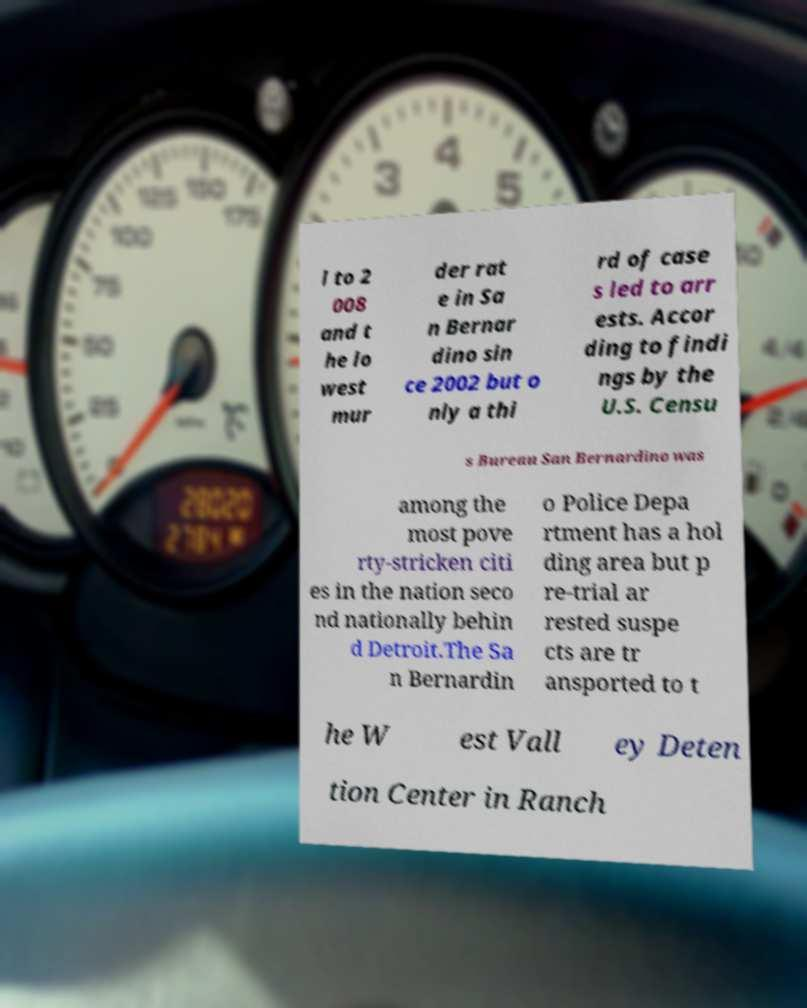For documentation purposes, I need the text within this image transcribed. Could you provide that? l to 2 008 and t he lo west mur der rat e in Sa n Bernar dino sin ce 2002 but o nly a thi rd of case s led to arr ests. Accor ding to findi ngs by the U.S. Censu s Bureau San Bernardino was among the most pove rty-stricken citi es in the nation seco nd nationally behin d Detroit.The Sa n Bernardin o Police Depa rtment has a hol ding area but p re-trial ar rested suspe cts are tr ansported to t he W est Vall ey Deten tion Center in Ranch 